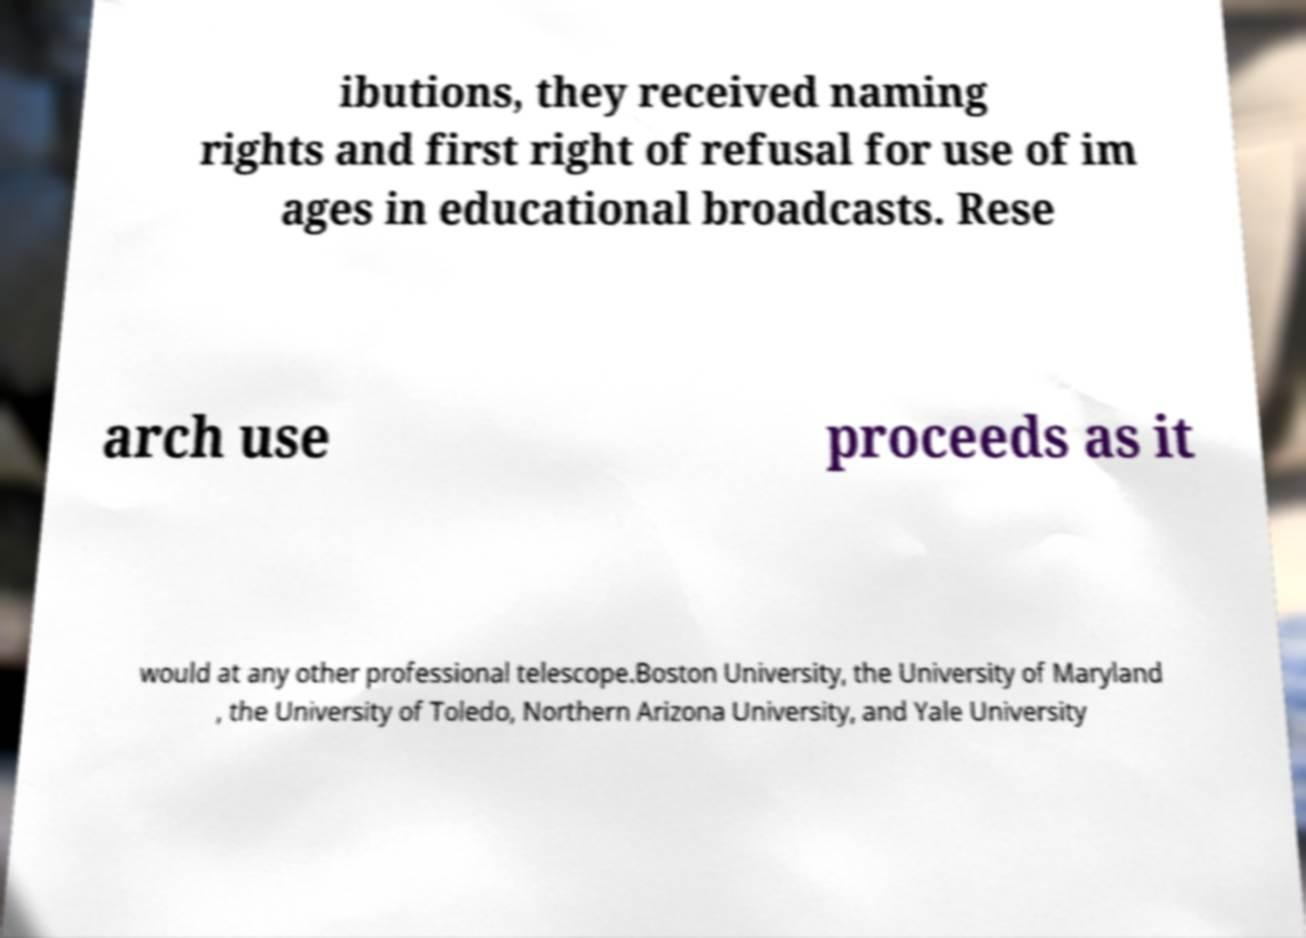There's text embedded in this image that I need extracted. Can you transcribe it verbatim? ibutions, they received naming rights and first right of refusal for use of im ages in educational broadcasts. Rese arch use proceeds as it would at any other professional telescope.Boston University, the University of Maryland , the University of Toledo, Northern Arizona University, and Yale University 